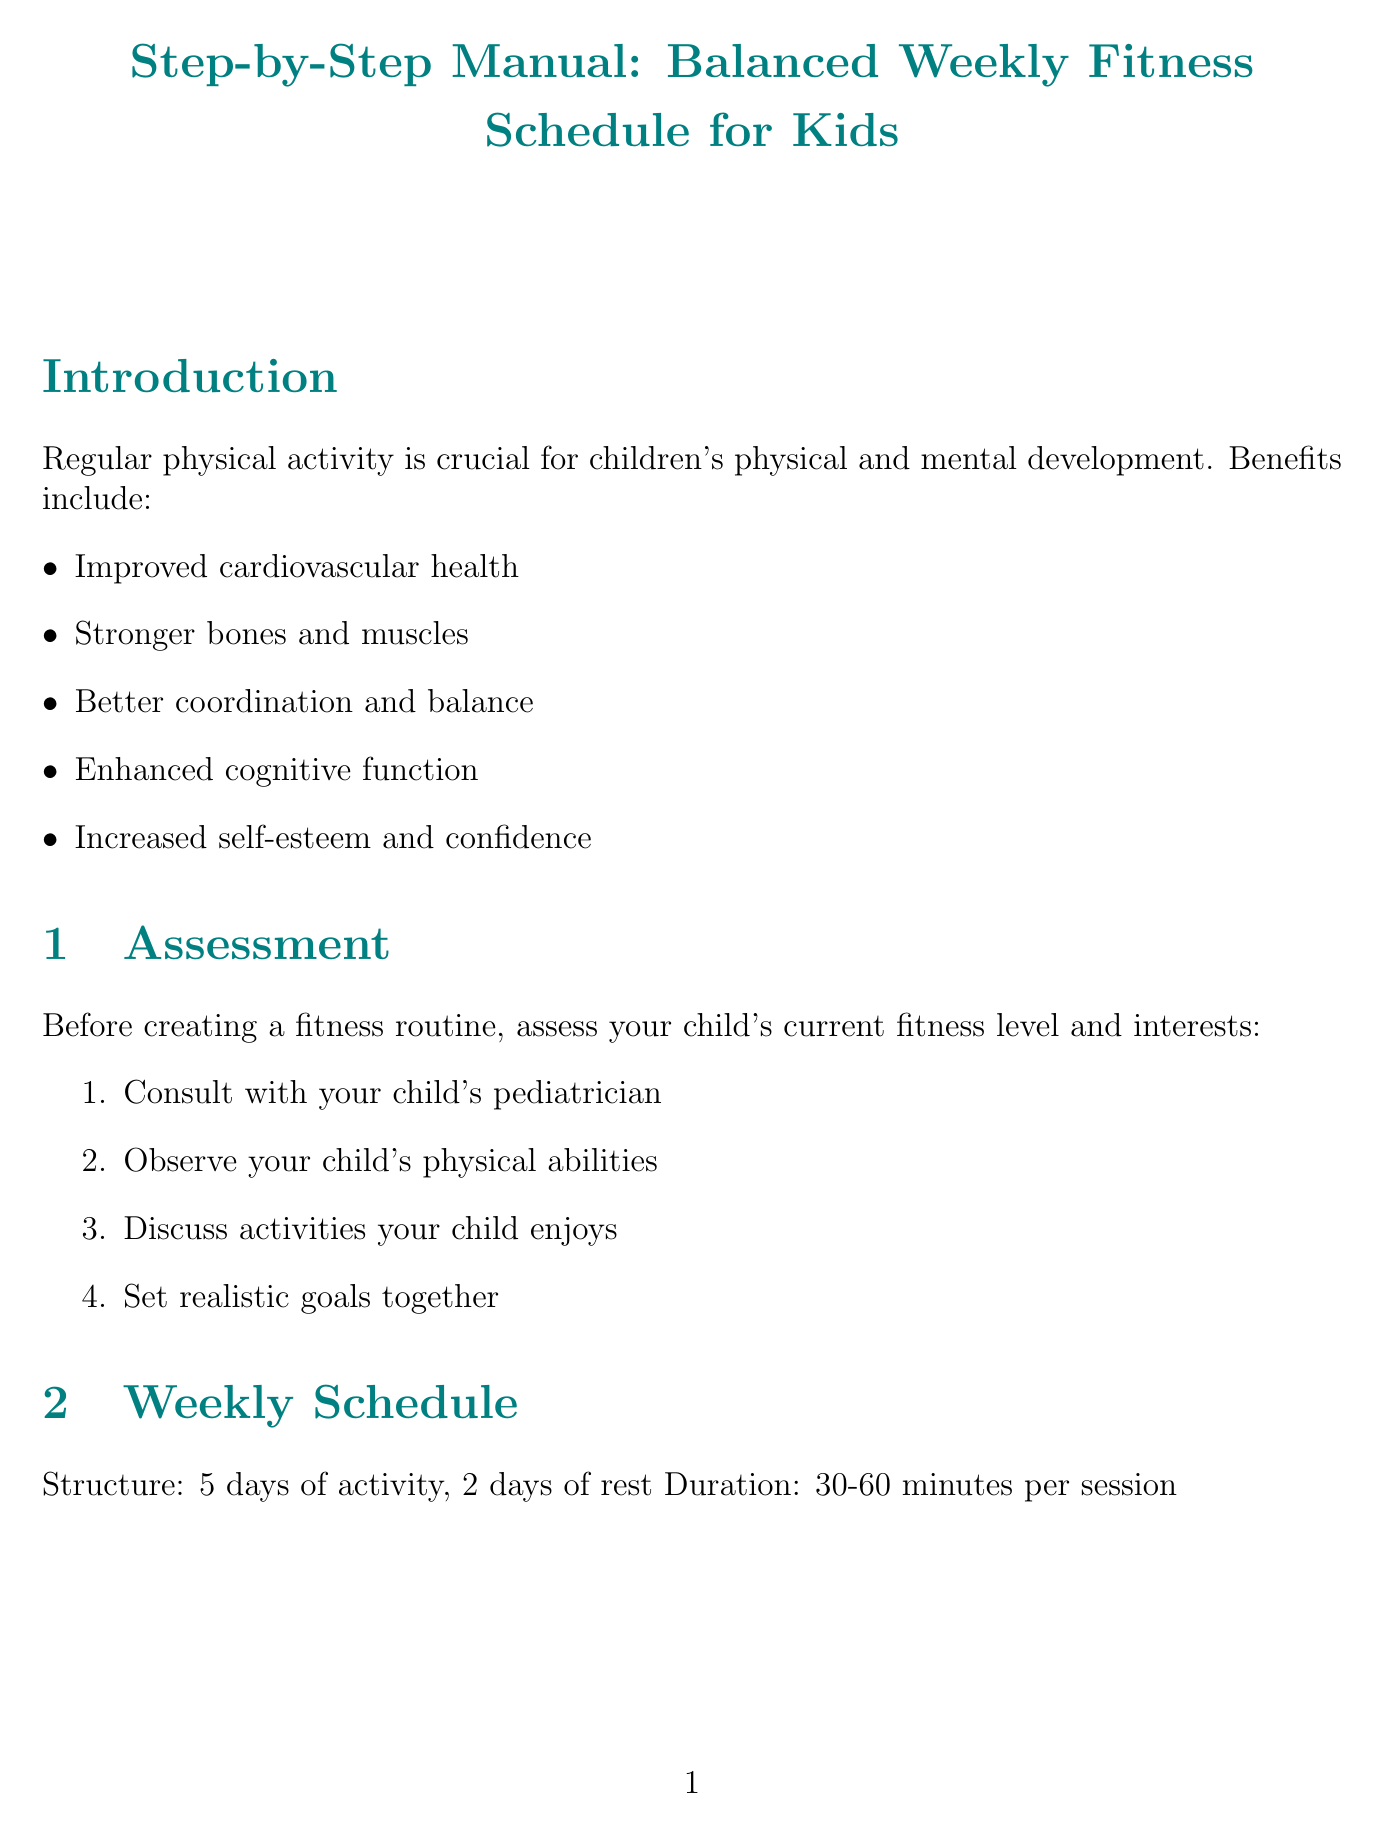What is the structure of the weekly schedule? The structure indicates how many days of activity and rest are included in the weekly schedule.
Answer: 5 days of activity, 2 days of rest What is the duration of each fitness session? The duration describes how long each fitness session should last within the weekly schedule.
Answer: 30-60 minutes per session List one example of a flexibility exercise. The document provides a list of exercises specifically focused on improving flexibility.
Answer: Butterfly stretch What type of activity is suggested for Thursday? The document outlines specific activities for each day of the week, including the type of activity designated for each day.
Answer: Cardio What is one safety guideline provided in the document? The document includes guidelines to ensure safety during physical activities for children.
Answer: Stay hydrated Why are nutrition tips included in the manual? The importance section explains the relevance of nutrition in relation to fitness for children.
Answer: Proper nutrition is essential to support your child's fitness routine What should younger children focus on during physical activities? The document outlines different focuses for activities based on the age group of the children.
Answer: Fun and basic motor skills What is a suggested motivation tip for kids' fitness? The manual provides specific strategies to keep children motivated in their fitness routine.
Answer: Make it fun and game-like How should progress be tracked according to the manual? The document offers methods to document improvements in a child's fitness journey.
Answer: Keep a fitness journal 